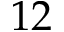<formula> <loc_0><loc_0><loc_500><loc_500>1 2</formula> 